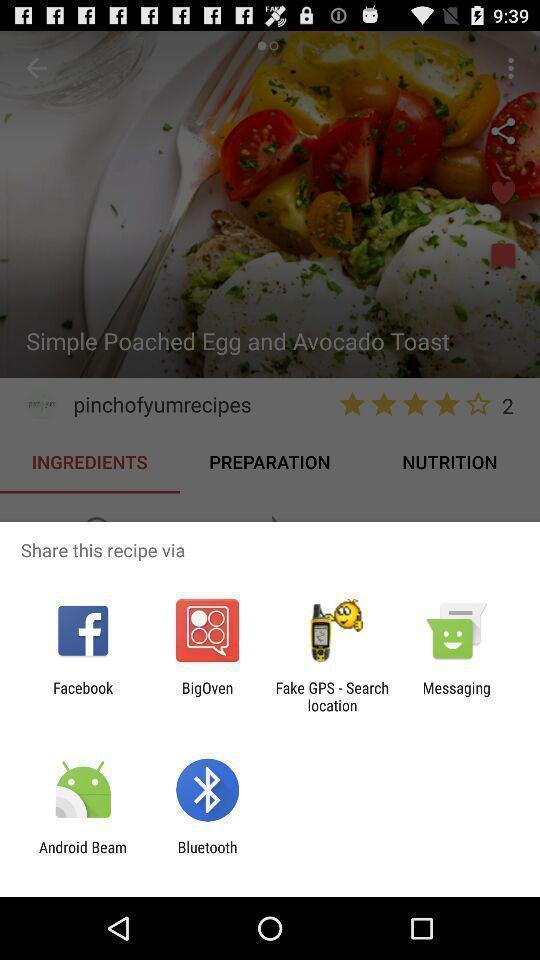Explain what's happening in this screen capture. Pop-up shows share recipe with multiple applications. 